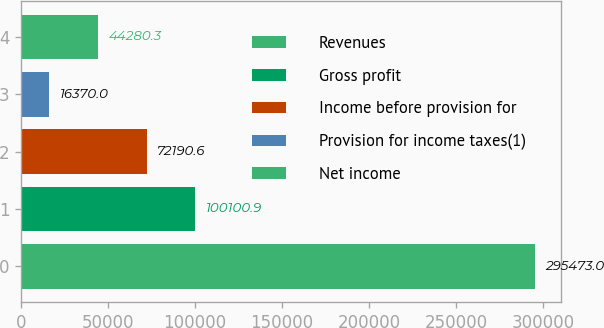Convert chart. <chart><loc_0><loc_0><loc_500><loc_500><bar_chart><fcel>Revenues<fcel>Gross profit<fcel>Income before provision for<fcel>Provision for income taxes(1)<fcel>Net income<nl><fcel>295473<fcel>100101<fcel>72190.6<fcel>16370<fcel>44280.3<nl></chart> 